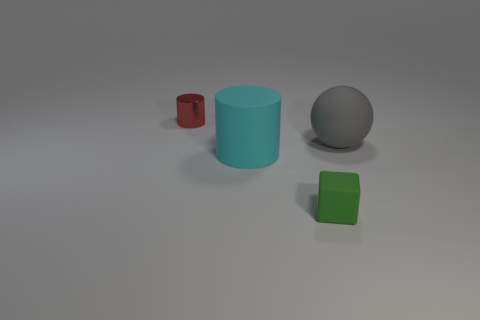Add 1 tiny gray balls. How many objects exist? 5 Subtract all blocks. How many objects are left? 3 Subtract 1 gray balls. How many objects are left? 3 Subtract all cyan rubber things. Subtract all cylinders. How many objects are left? 1 Add 2 rubber balls. How many rubber balls are left? 3 Add 3 tiny rubber cubes. How many tiny rubber cubes exist? 4 